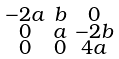Convert formula to latex. <formula><loc_0><loc_0><loc_500><loc_500>\begin{smallmatrix} - 2 a & b & 0 \\ 0 & a & - 2 b \\ 0 & 0 & 4 a \end{smallmatrix}</formula> 